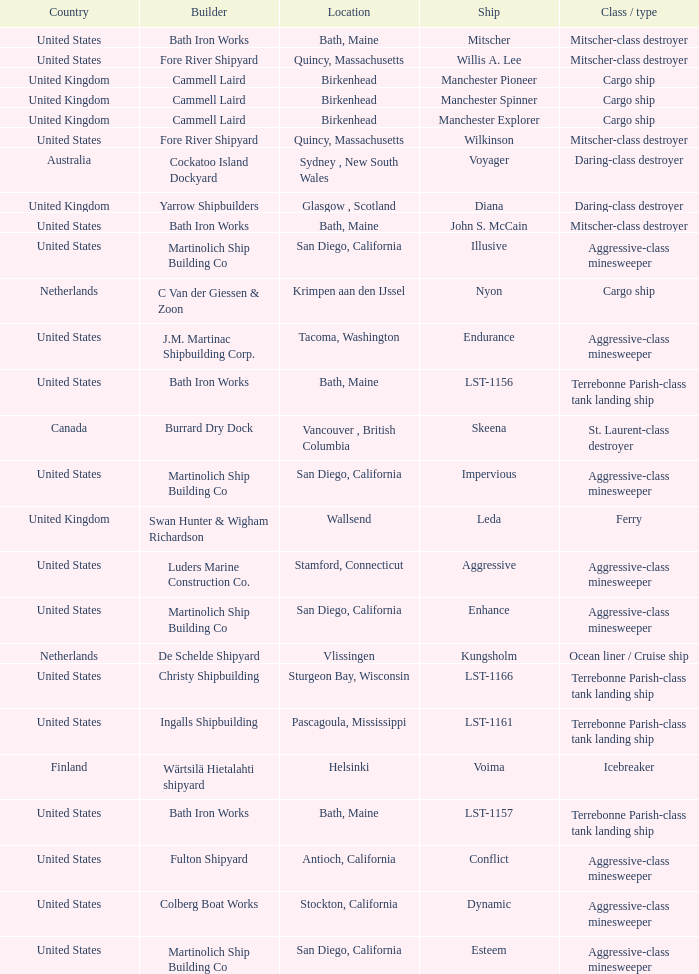What is the Cargo Ship located at Birkenhead? Manchester Pioneer, Manchester Spinner, Manchester Explorer. 